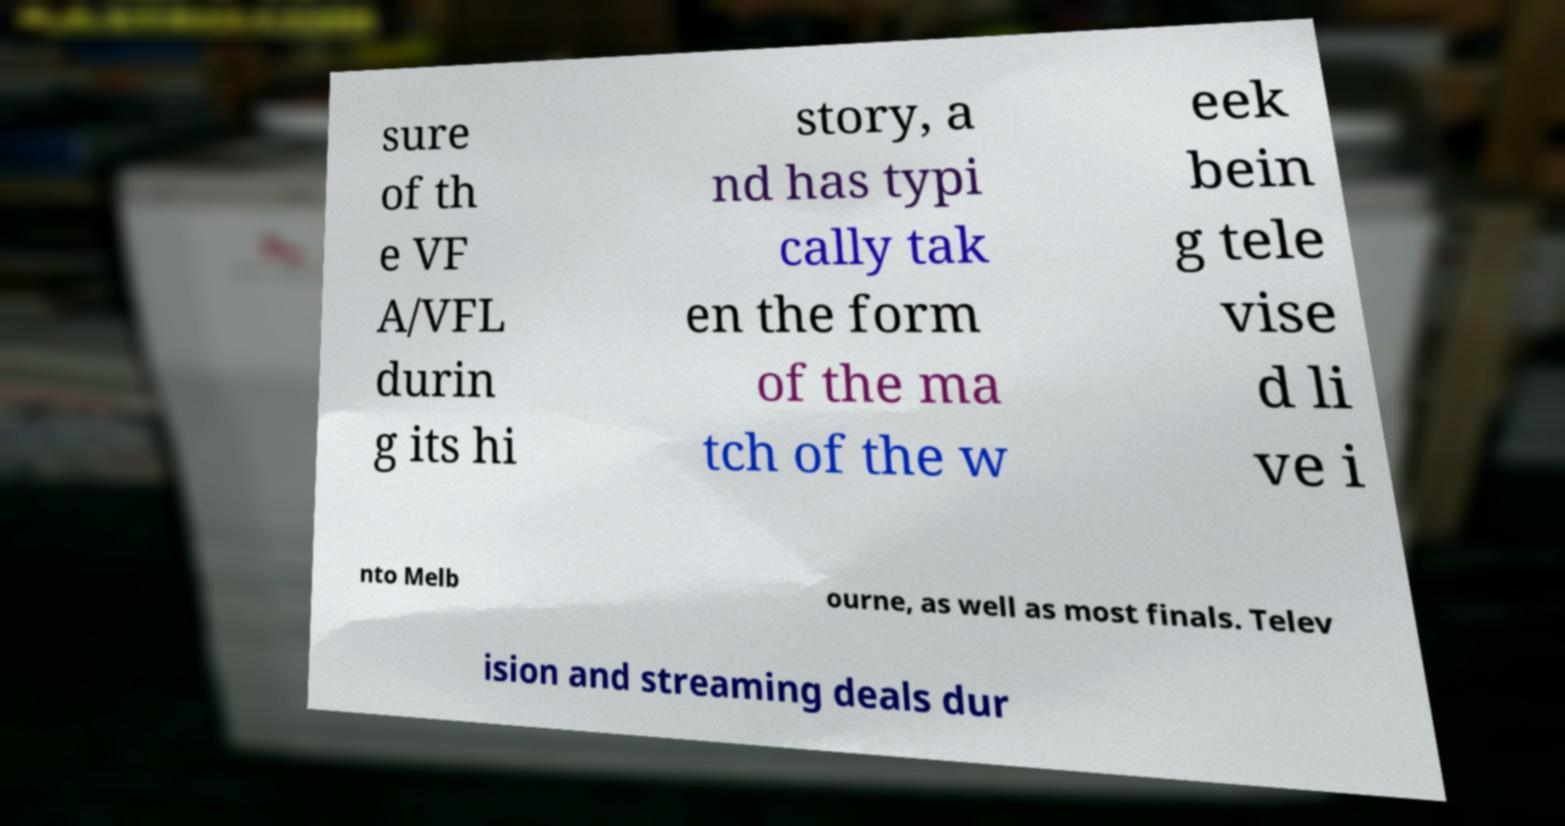What messages or text are displayed in this image? I need them in a readable, typed format. sure of th e VF A/VFL durin g its hi story, a nd has typi cally tak en the form of the ma tch of the w eek bein g tele vise d li ve i nto Melb ourne, as well as most finals. Telev ision and streaming deals dur 